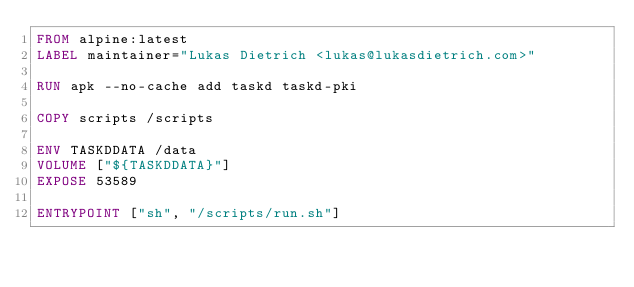<code> <loc_0><loc_0><loc_500><loc_500><_Dockerfile_>FROM alpine:latest
LABEL maintainer="Lukas Dietrich <lukas@lukasdietrich.com>"

RUN apk --no-cache add taskd taskd-pki

COPY scripts /scripts

ENV TASKDDATA /data
VOLUME ["${TASKDDATA}"]
EXPOSE 53589

ENTRYPOINT ["sh", "/scripts/run.sh"]
</code> 